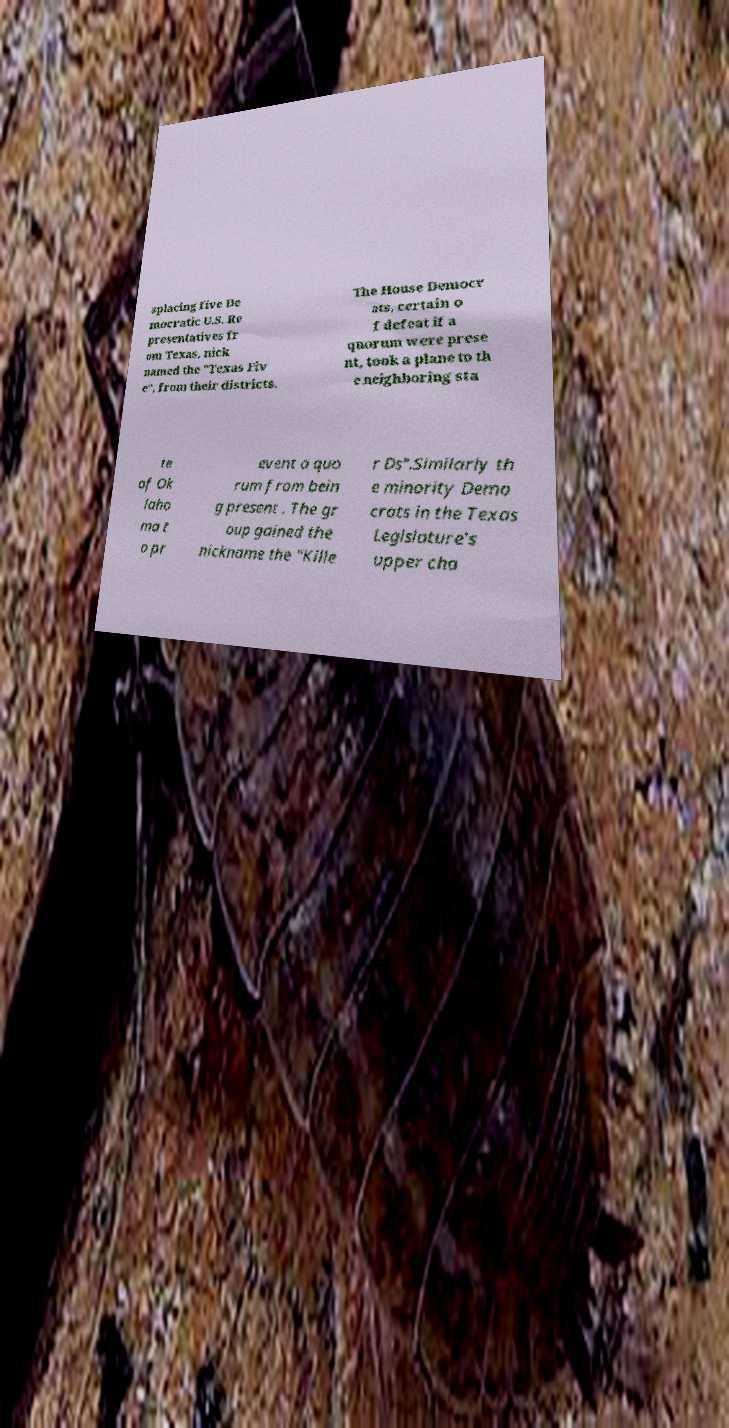Could you extract and type out the text from this image? splacing five De mocratic U.S. Re presentatives fr om Texas, nick named the "Texas Fiv e", from their districts. The House Democr ats, certain o f defeat if a quorum were prese nt, took a plane to th e neighboring sta te of Ok laho ma t o pr event a quo rum from bein g present . The gr oup gained the nickname the "Kille r Ds".Similarly th e minority Demo crats in the Texas Legislature's upper cha 